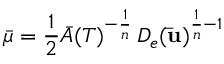<formula> <loc_0><loc_0><loc_500><loc_500>\bar { \mu } = \frac { 1 } { 2 } \bar { A } ( T ) ^ { - \frac { 1 } { n } } \, D _ { e } ( \bar { u } ) ^ { \frac { 1 } { n } - 1 }</formula> 